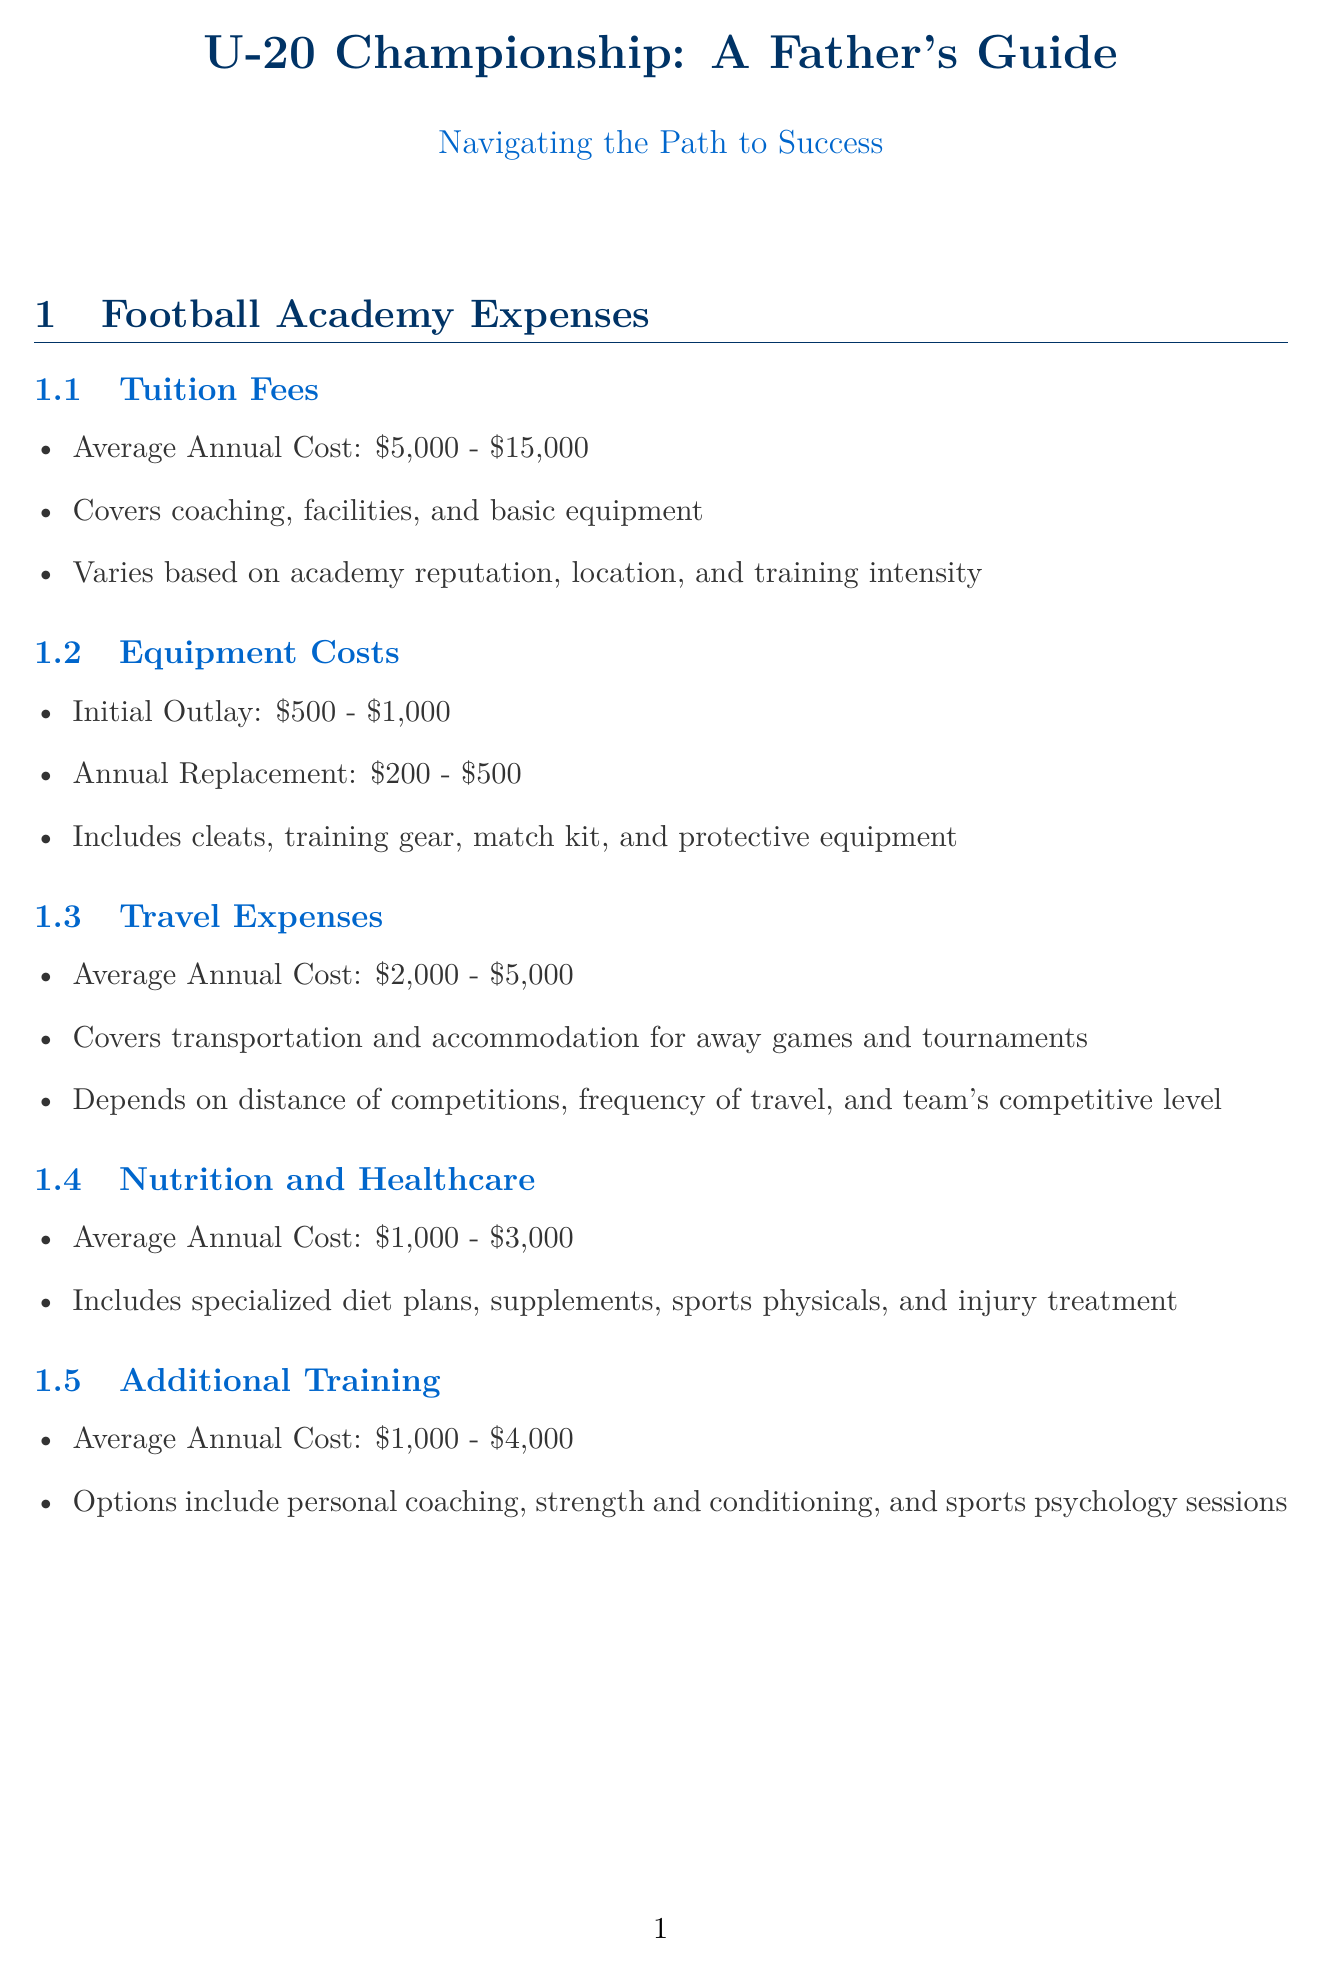What is the average annual cost of tuition fees? The average annual cost of tuition fees ranges from five thousand to fifteen thousand dollars.
Answer: $5,000 - $15,000 What items are included in equipment costs? The document lists cleats, training gear, match kit, and protective equipment as included items in equipment costs.
Answer: Cleats, training gear, match kit, protective equipment What is the scholarship value from the Pelé Foundation? The document states that the Pelé Foundation offers a scholarship value of up to ten thousand dollars.
Answer: Up to $10,000 What key milestone should a player aim to achieve by age 14-15? Players should aim to join a reputable youth academy by age 14-15 as one of the key milestones for preparation.
Answer: Join reputable youth academy What are the weekly training hours commitment? The document specifies that the weekly training commitment is between fifteen to twenty hours.
Answer: 15-20 hours What does the U.S. Soccer Foundation focus on for their scholarships? The U.S. Soccer Foundation focuses their scholarships on underprivileged youth with soccer potential.
Answer: Underprivileged youth with soccer potential What is one strategy for managing family life balance? One suggested strategy for managing family life balance is to plan non-soccer family activities.
Answer: Plan non-soccer family activities What educational consideration is highlighted in the document? The document highlights the balance between academic and soccer commitments as an important consideration for educational planning.
Answer: Balance between academic and soccer commitments What is the average cost of nutrition and healthcare annually? The average annual cost for nutrition and healthcare ranges from one thousand to three thousand dollars.
Answer: $1,000 - $3,000 